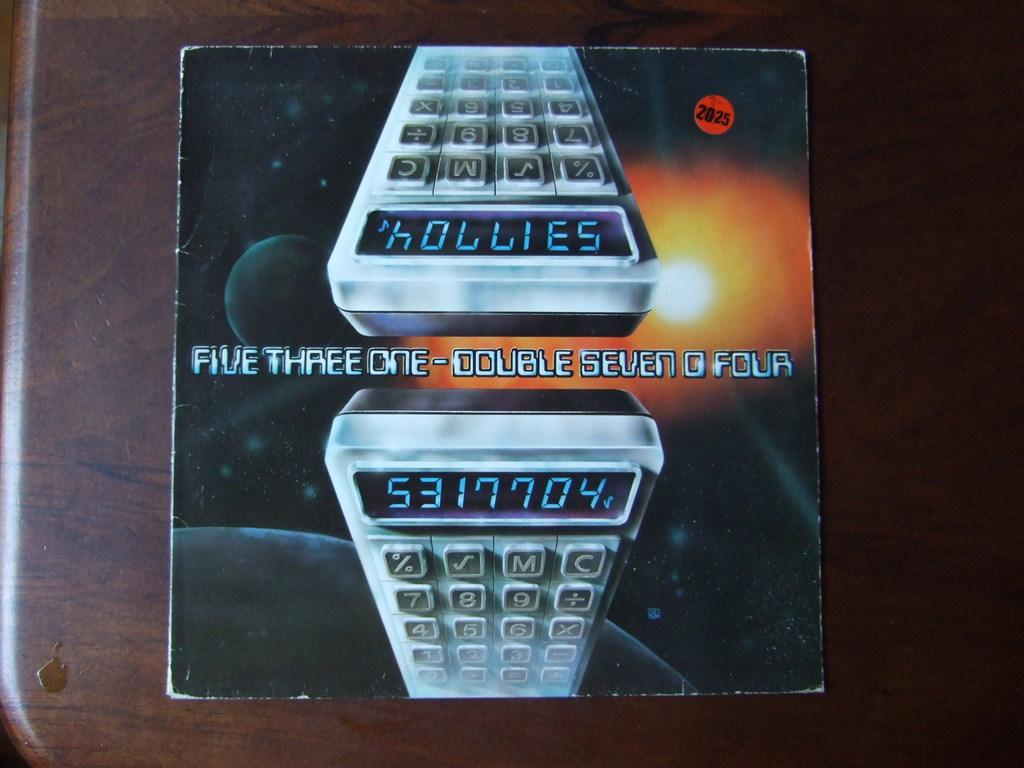<image>
Offer a succinct explanation of the picture presented. A product box with the words Five Three On-Double Seven O Four in the center and a picture of a calculator 